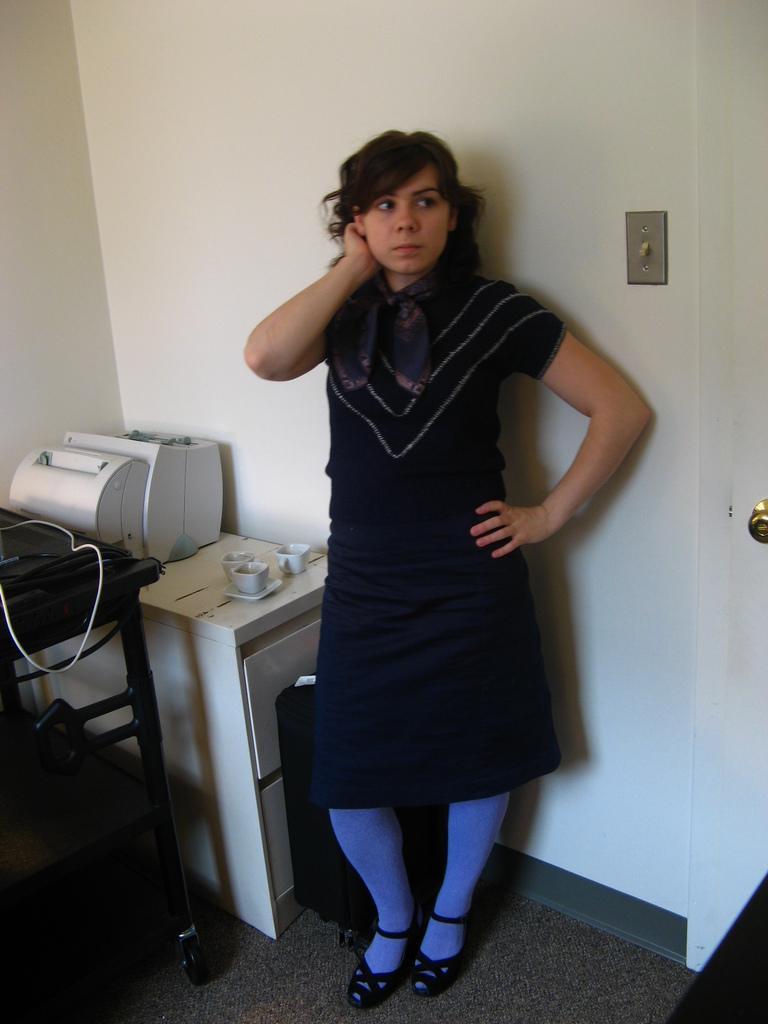Can you describe this image briefly? a person is standing wearing a black dress. behind her there is a white wall. 